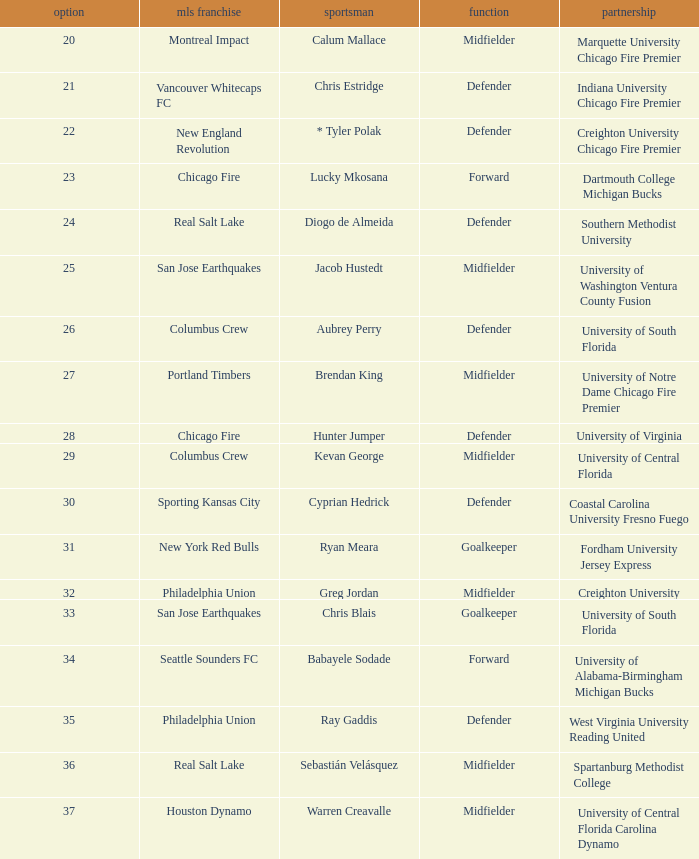Would you mind parsing the complete table? {'header': ['option', 'mls franchise', 'sportsman', 'function', 'partnership'], 'rows': [['20', 'Montreal Impact', 'Calum Mallace', 'Midfielder', 'Marquette University Chicago Fire Premier'], ['21', 'Vancouver Whitecaps FC', 'Chris Estridge', 'Defender', 'Indiana University Chicago Fire Premier'], ['22', 'New England Revolution', '* Tyler Polak', 'Defender', 'Creighton University Chicago Fire Premier'], ['23', 'Chicago Fire', 'Lucky Mkosana', 'Forward', 'Dartmouth College Michigan Bucks'], ['24', 'Real Salt Lake', 'Diogo de Almeida', 'Defender', 'Southern Methodist University'], ['25', 'San Jose Earthquakes', 'Jacob Hustedt', 'Midfielder', 'University of Washington Ventura County Fusion'], ['26', 'Columbus Crew', 'Aubrey Perry', 'Defender', 'University of South Florida'], ['27', 'Portland Timbers', 'Brendan King', 'Midfielder', 'University of Notre Dame Chicago Fire Premier'], ['28', 'Chicago Fire', 'Hunter Jumper', 'Defender', 'University of Virginia'], ['29', 'Columbus Crew', 'Kevan George', 'Midfielder', 'University of Central Florida'], ['30', 'Sporting Kansas City', 'Cyprian Hedrick', 'Defender', 'Coastal Carolina University Fresno Fuego'], ['31', 'New York Red Bulls', 'Ryan Meara', 'Goalkeeper', 'Fordham University Jersey Express'], ['32', 'Philadelphia Union', 'Greg Jordan', 'Midfielder', 'Creighton University'], ['33', 'San Jose Earthquakes', 'Chris Blais', 'Goalkeeper', 'University of South Florida'], ['34', 'Seattle Sounders FC', 'Babayele Sodade', 'Forward', 'University of Alabama-Birmingham Michigan Bucks'], ['35', 'Philadelphia Union', 'Ray Gaddis', 'Defender', 'West Virginia University Reading United'], ['36', 'Real Salt Lake', 'Sebastián Velásquez', 'Midfielder', 'Spartanburg Methodist College'], ['37', 'Houston Dynamo', 'Warren Creavalle', 'Midfielder', 'University of Central Florida Carolina Dynamo']]} What MLS team picked Babayele Sodade? Seattle Sounders FC. 